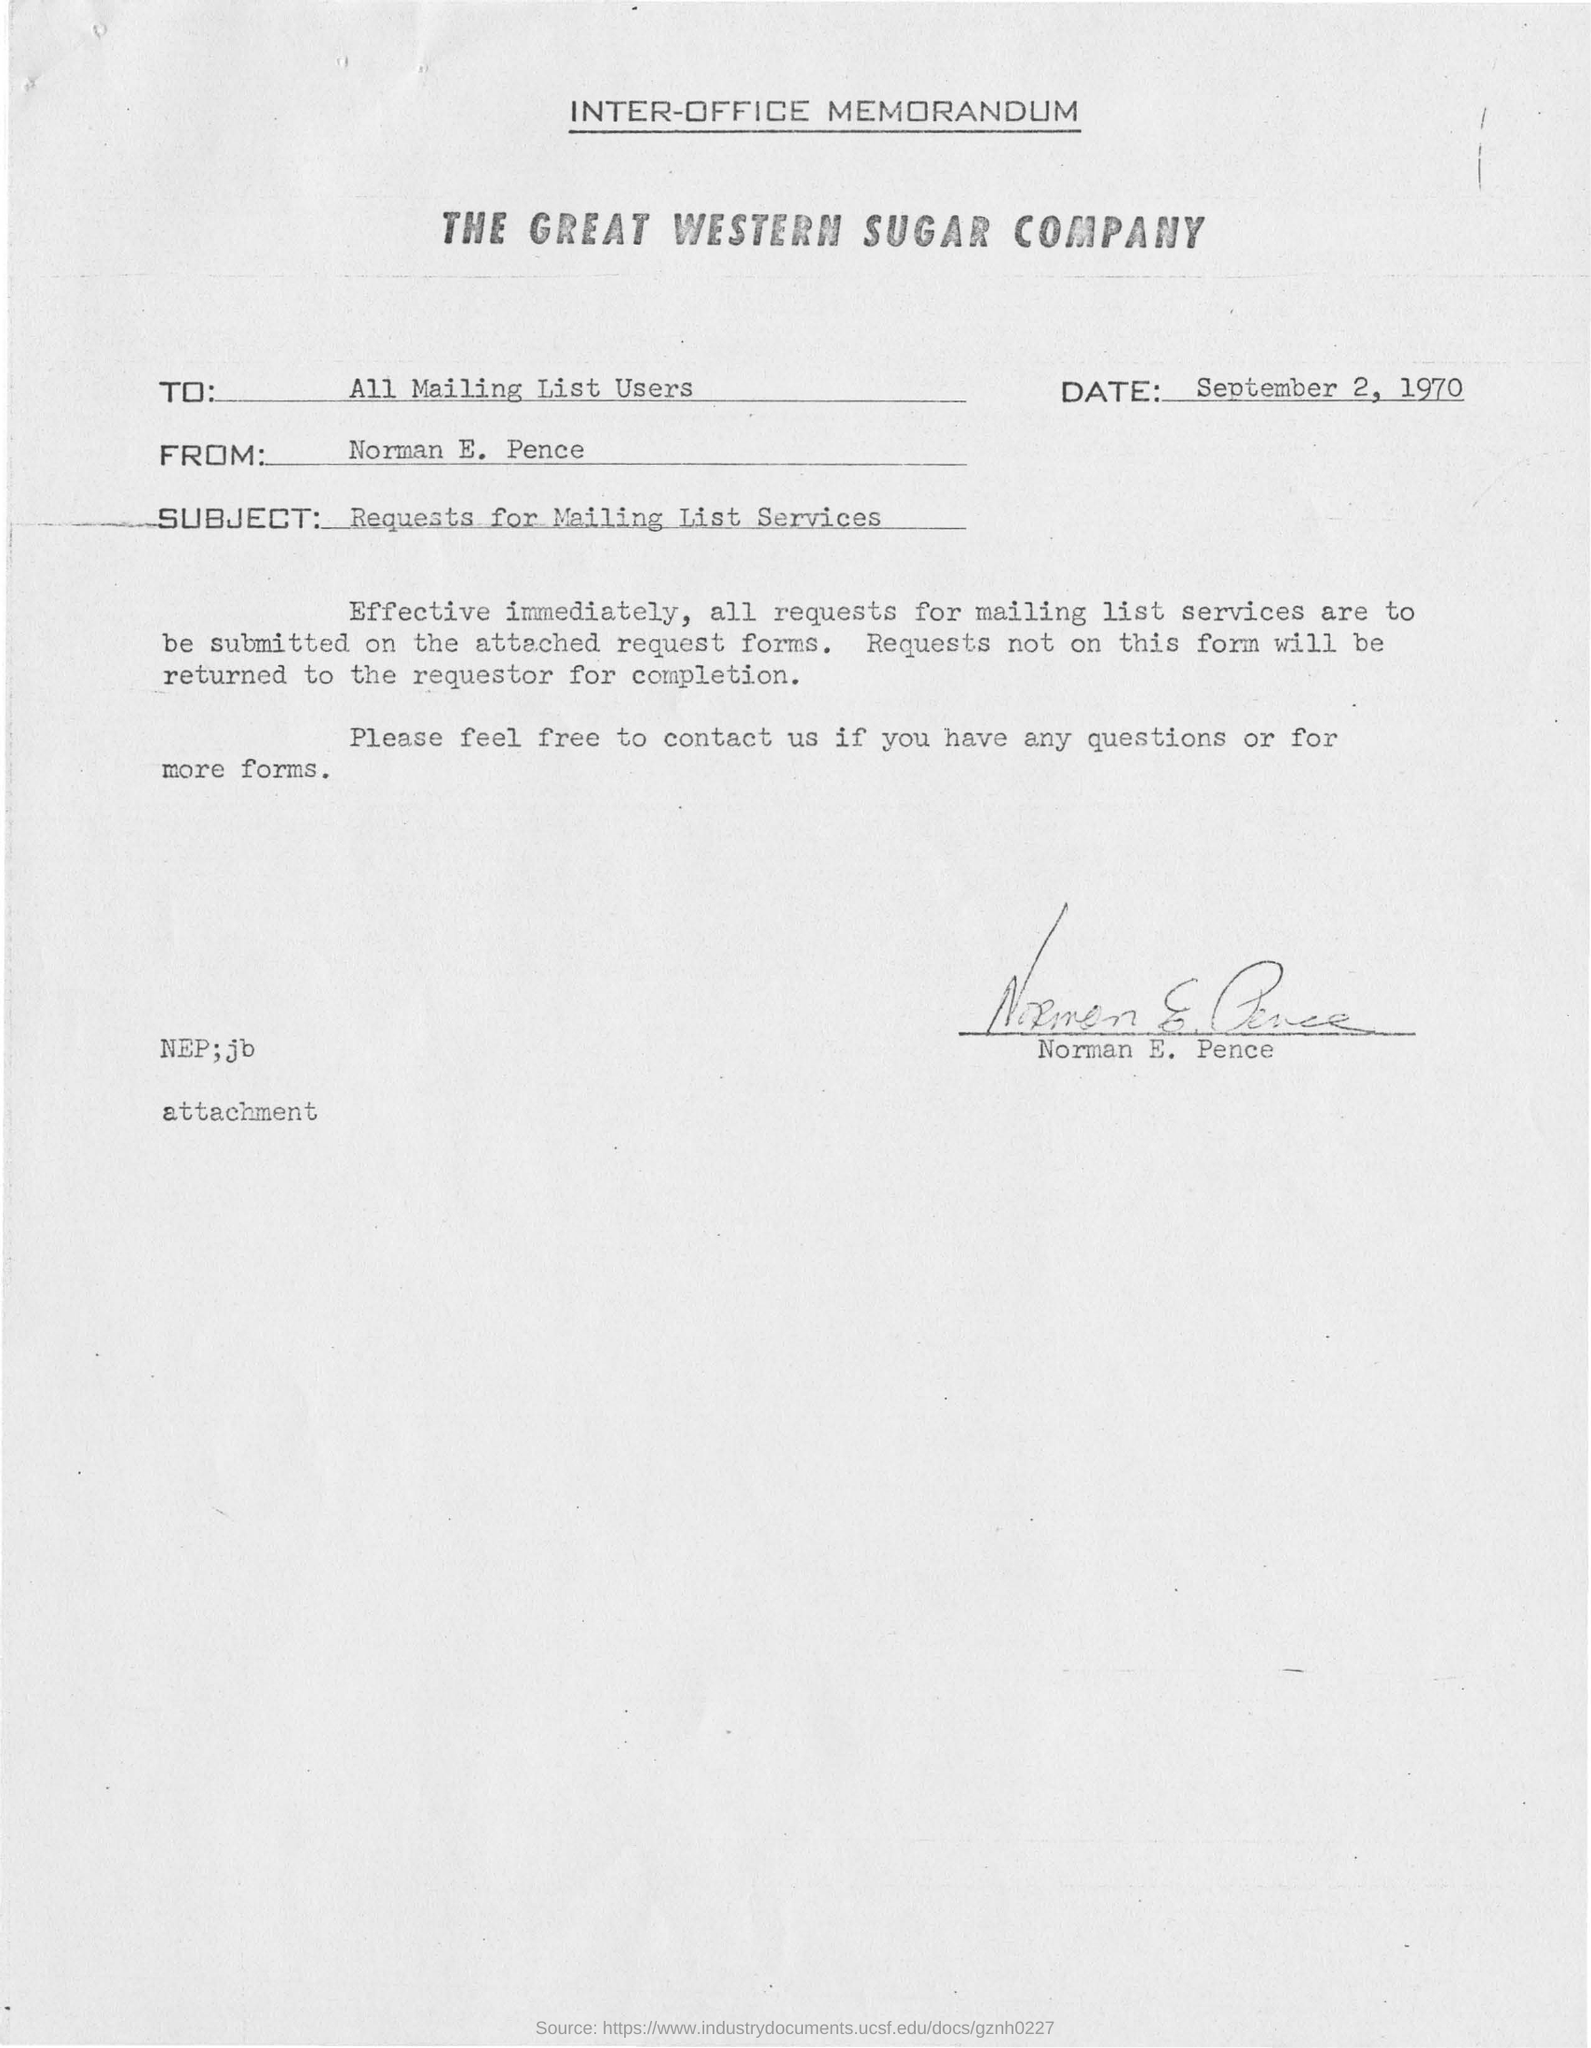Give some essential details in this illustration. The date mentioned in the memorandum is September 2, 1970. The subject mentioned is what is the subject mentioned. Requests for mailing list services are being made. The signature of Norman E. Pence appears on this memorandum. The letter was addressed to all users of the mailing list. The inter office memorandum mentions the company "The Great Western Sugar Company. 